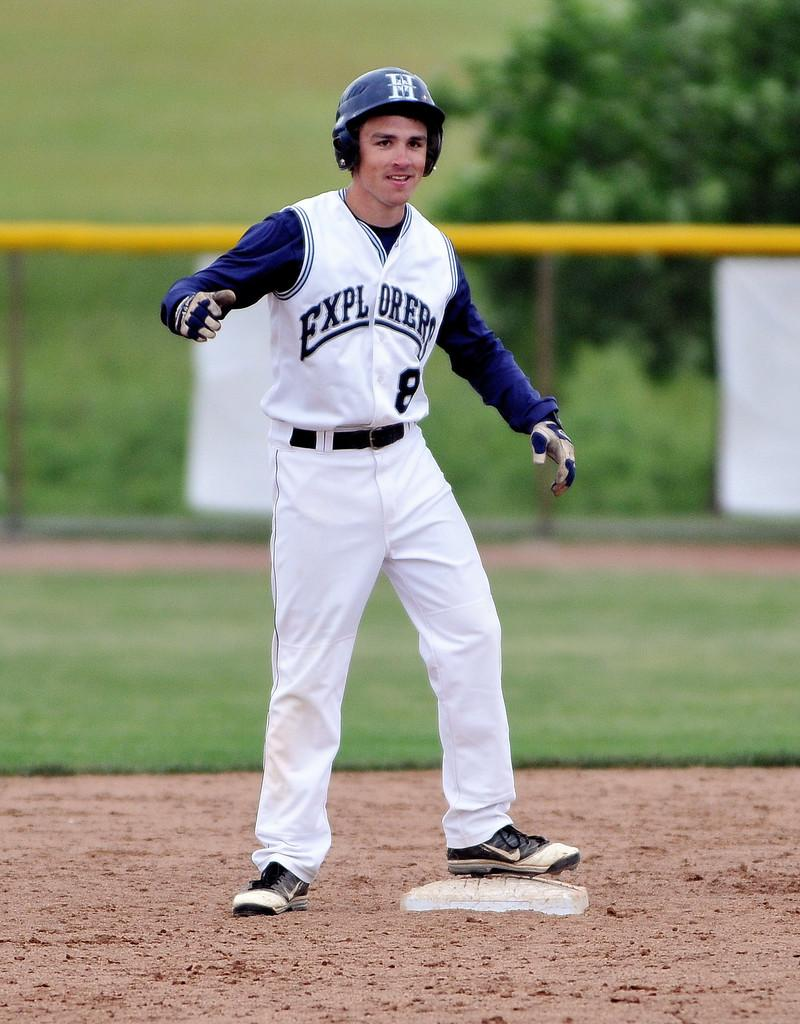<image>
Summarize the visual content of the image. Player number eight of the Explorers with his foot on a base. 